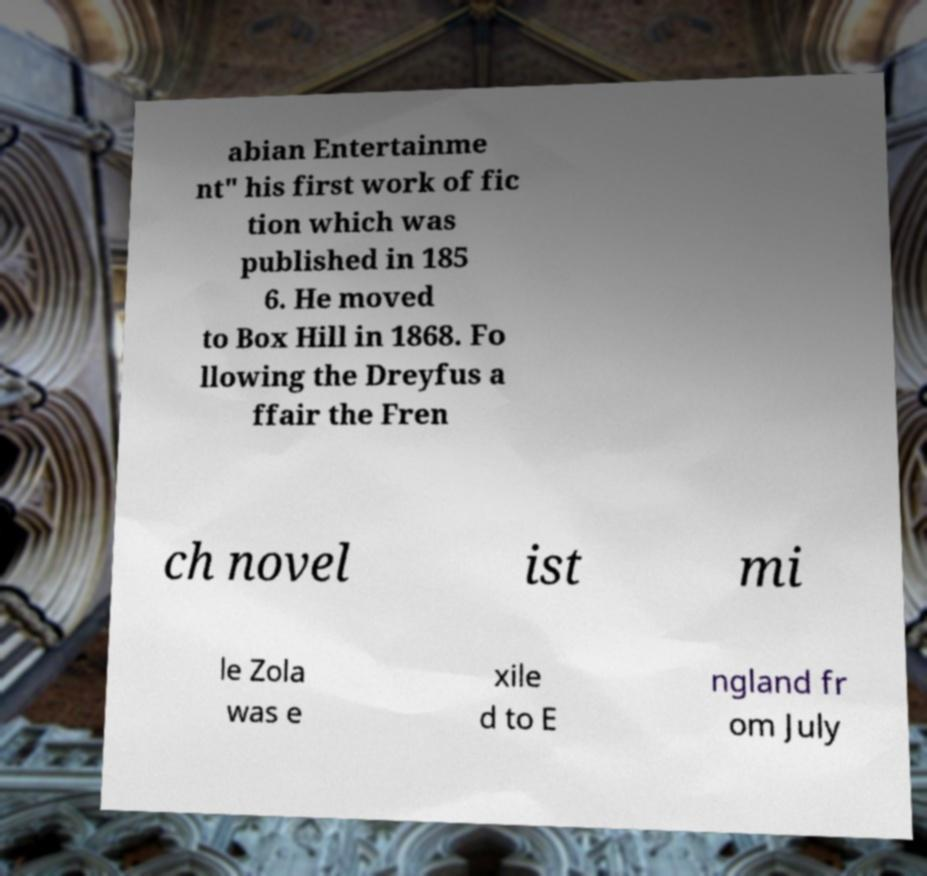I need the written content from this picture converted into text. Can you do that? abian Entertainme nt" his first work of fic tion which was published in 185 6. He moved to Box Hill in 1868. Fo llowing the Dreyfus a ffair the Fren ch novel ist mi le Zola was e xile d to E ngland fr om July 